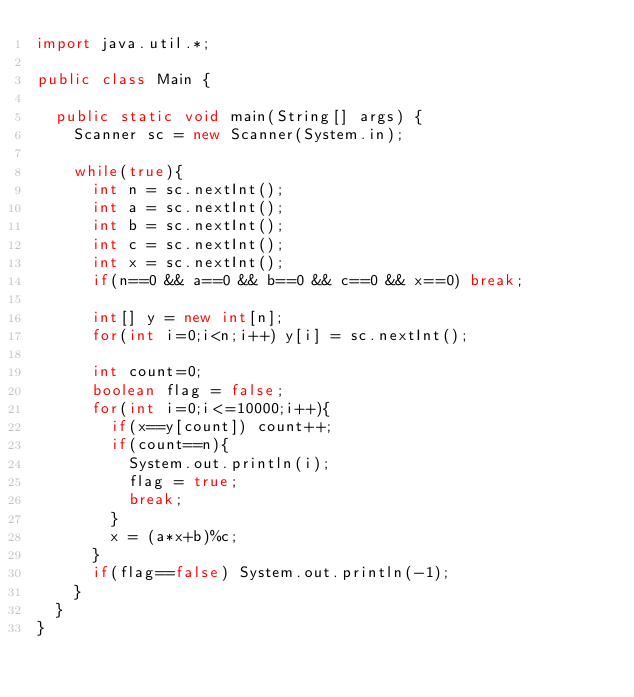Convert code to text. <code><loc_0><loc_0><loc_500><loc_500><_Java_>import java.util.*;

public class Main {
	
	public static void main(String[] args) {
		Scanner sc = new Scanner(System.in);
		
		while(true){
			int n = sc.nextInt();
			int a = sc.nextInt();
			int b = sc.nextInt();
			int c = sc.nextInt();
			int x = sc.nextInt();
			if(n==0 && a==0 && b==0 && c==0 && x==0) break;
			
			int[] y = new int[n];
			for(int i=0;i<n;i++) y[i] = sc.nextInt();
			
			int count=0;
			boolean flag = false;
			for(int i=0;i<=10000;i++){
				if(x==y[count]) count++;
				if(count==n){
					System.out.println(i);
					flag = true;
					break;
				}
				x = (a*x+b)%c;
			}
			if(flag==false) System.out.println(-1);
		}	
	}	
}</code> 